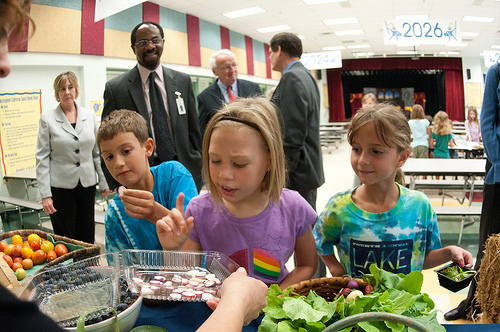<image>
Can you confirm if the woman is behind the table? No. The woman is not behind the table. From this viewpoint, the woman appears to be positioned elsewhere in the scene. 